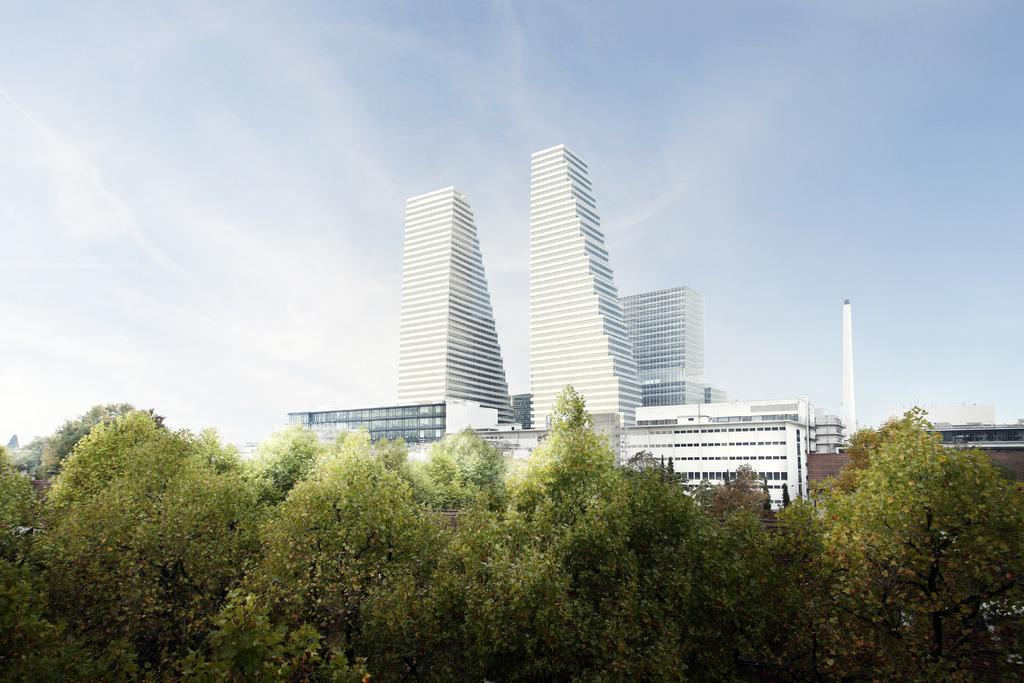What type of structures can be seen in the image? There are buildings in the image. What other natural elements are present in the image? There are trees in the image. Can you describe the white-colored object in the image? There is a white-colored object in the image, but its specific nature is not clear from the provided facts. What is visible in the background of the image? The sky is visible in the image. How many sacks are being copied quietly in the image? There are no sacks or any copying or quiet activities depicted in the image. 